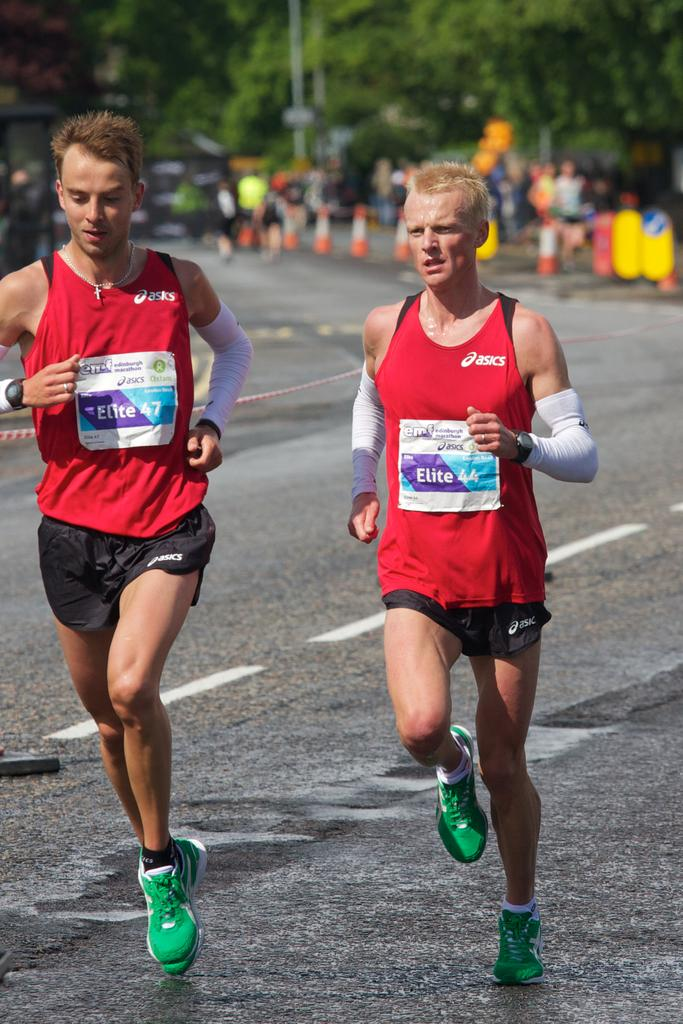Provide a one-sentence caption for the provided image. Two men race in the Edinburgh Marathon in asics jerseys.. 